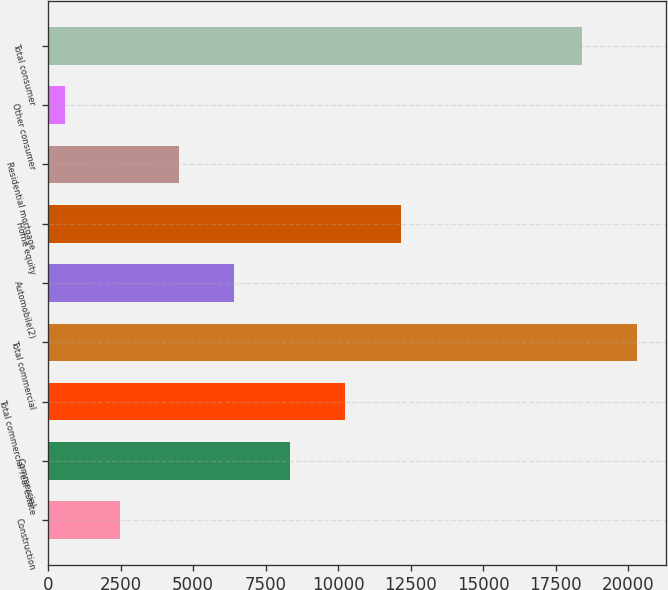Convert chart. <chart><loc_0><loc_0><loc_500><loc_500><bar_chart><fcel>Construction<fcel>Commercial<fcel>Total commercial real estate<fcel>Total commercial<fcel>Automobile(2)<fcel>Home equity<fcel>Residential mortgage<fcel>Other consumer<fcel>Total consumer<nl><fcel>2480.8<fcel>8329.6<fcel>10244.4<fcel>20307.8<fcel>6414.8<fcel>12159.2<fcel>4500<fcel>566<fcel>18393<nl></chart> 